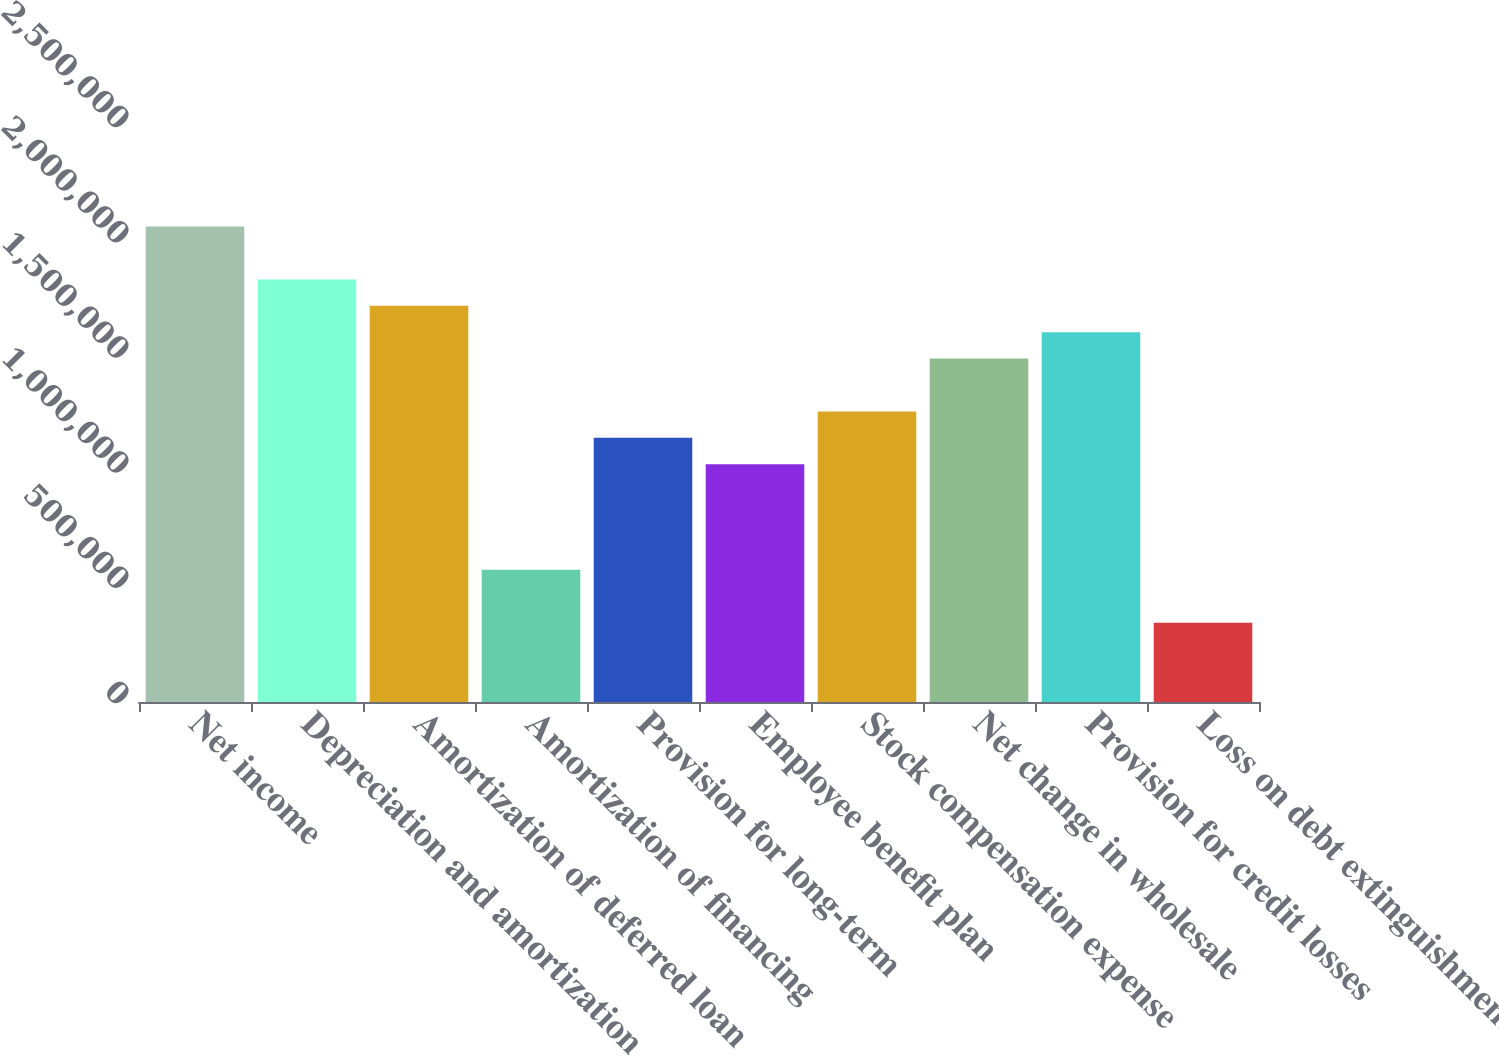<chart> <loc_0><loc_0><loc_500><loc_500><bar_chart><fcel>Net income<fcel>Depreciation and amortization<fcel>Amortization of deferred loan<fcel>Amortization of financing<fcel>Provision for long-term<fcel>Employee benefit plan<fcel>Stock compensation expense<fcel>Net change in wholesale<fcel>Provision for credit losses<fcel>Loss on debt extinguishment<nl><fcel>2.06346e+06<fcel>1.83426e+06<fcel>1.71966e+06<fcel>573690<fcel>1.14668e+06<fcel>1.03208e+06<fcel>1.26127e+06<fcel>1.49047e+06<fcel>1.60507e+06<fcel>344495<nl></chart> 